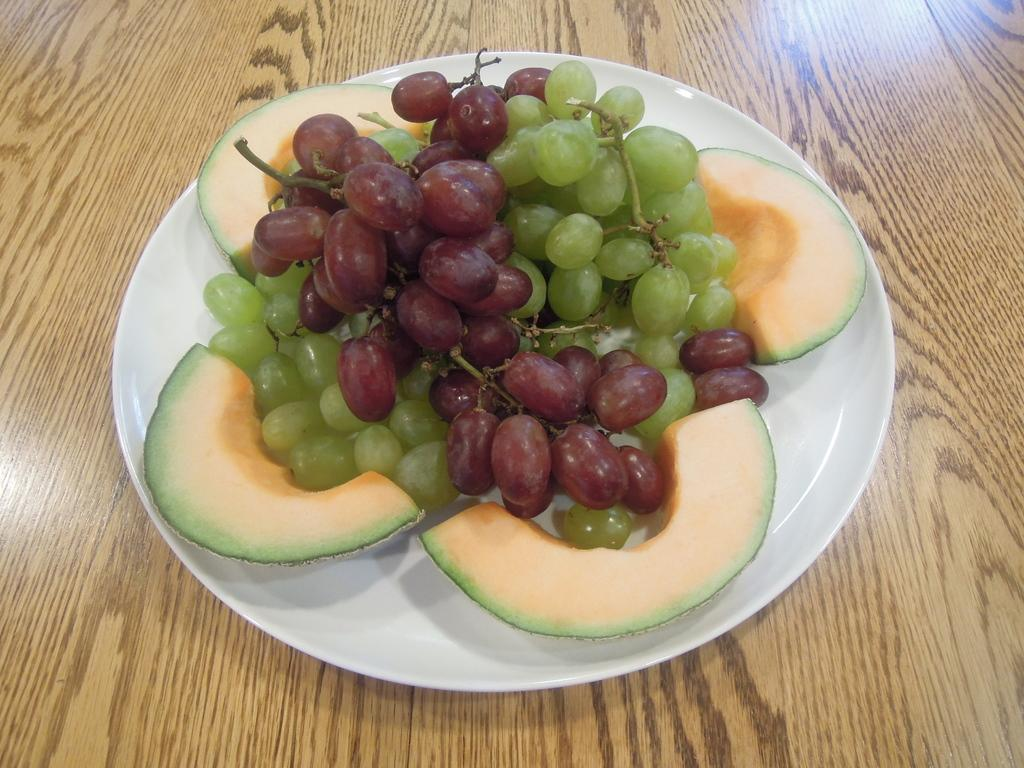What is located in the middle of the image? There is a plate in the middle of the image. What is on the plate? The plate contains different types of fruits. How many years does the plate have? The plate does not have a specific number of years; it is an object in the image, and the concept of years does not apply to it. 